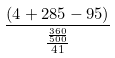Convert formula to latex. <formula><loc_0><loc_0><loc_500><loc_500>\frac { ( 4 + 2 8 5 - 9 5 ) } { \frac { \frac { 3 6 0 } { 5 0 0 } } { 4 1 } }</formula> 